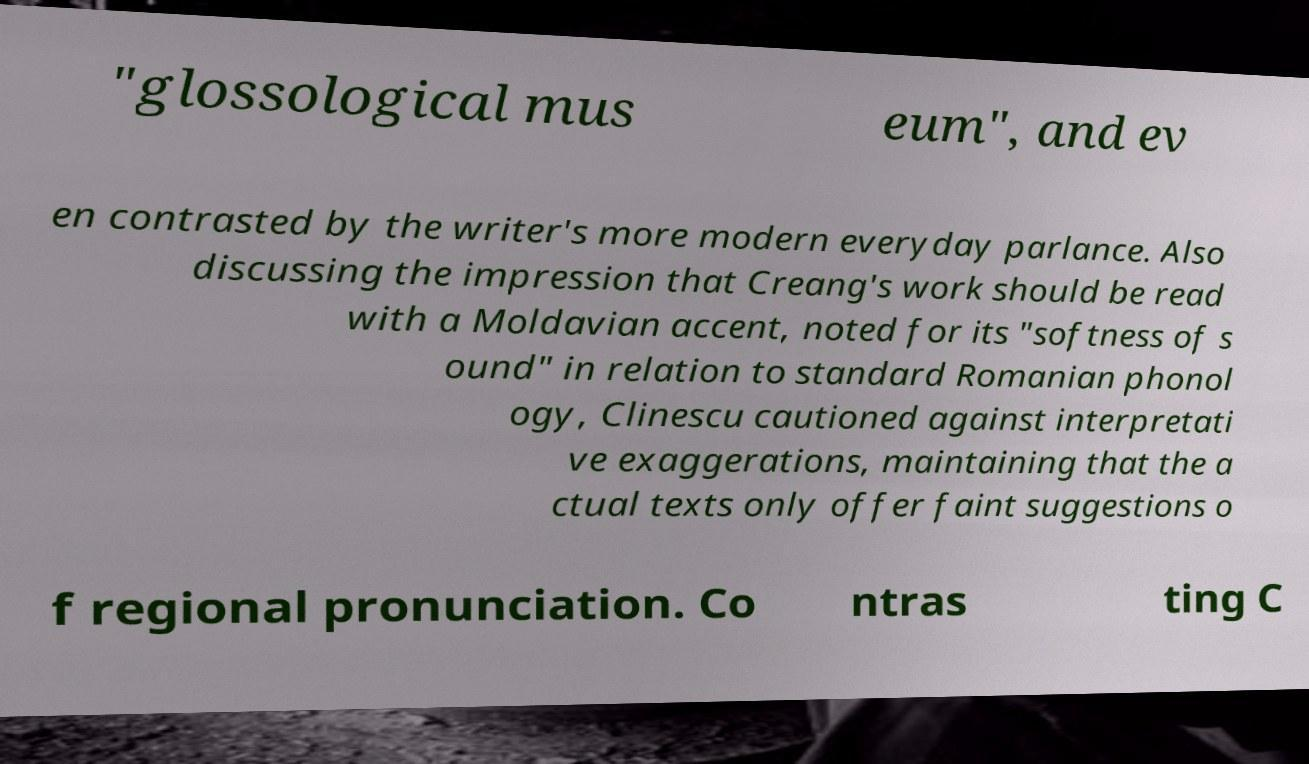What messages or text are displayed in this image? I need them in a readable, typed format. "glossological mus eum", and ev en contrasted by the writer's more modern everyday parlance. Also discussing the impression that Creang's work should be read with a Moldavian accent, noted for its "softness of s ound" in relation to standard Romanian phonol ogy, Clinescu cautioned against interpretati ve exaggerations, maintaining that the a ctual texts only offer faint suggestions o f regional pronunciation. Co ntras ting C 